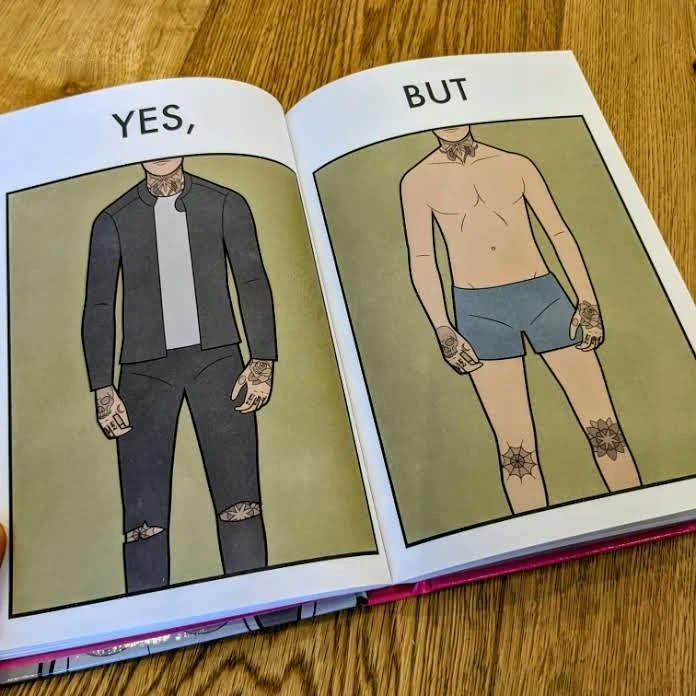Describe what you see in the left and right parts of this image. In the left part of the image: a person wearing black clothes, having neck, hand, and knee tattoos. In the right part of the image: a person wearing shorts, having neck, hand, and knee tattoos. 